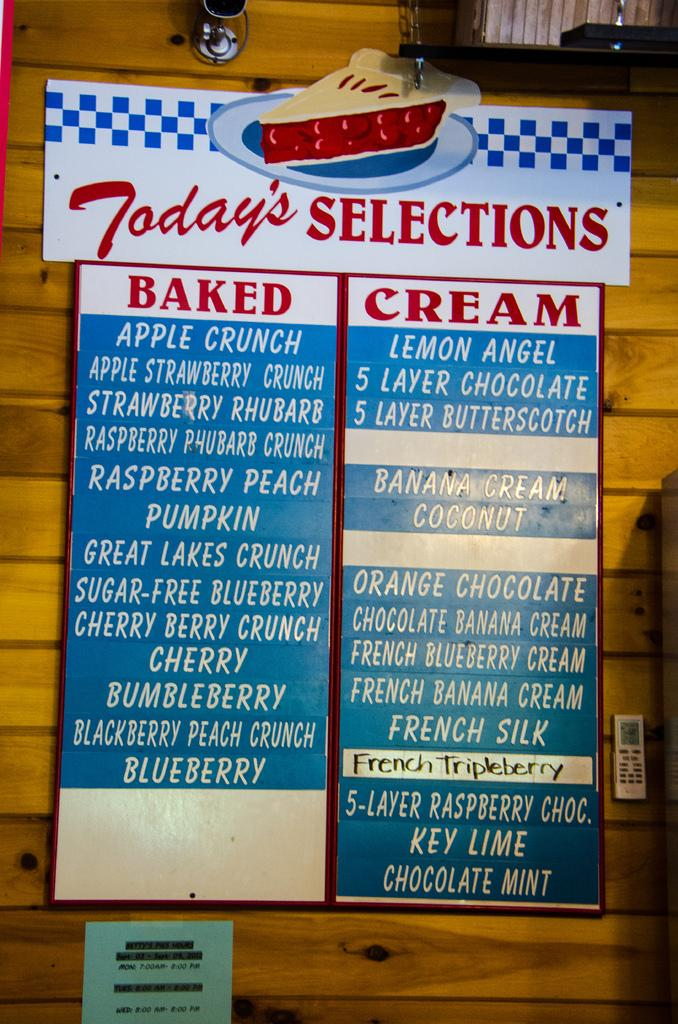<image>
Provide a brief description of the given image. A menu shows Today's selections at an restaurant. 